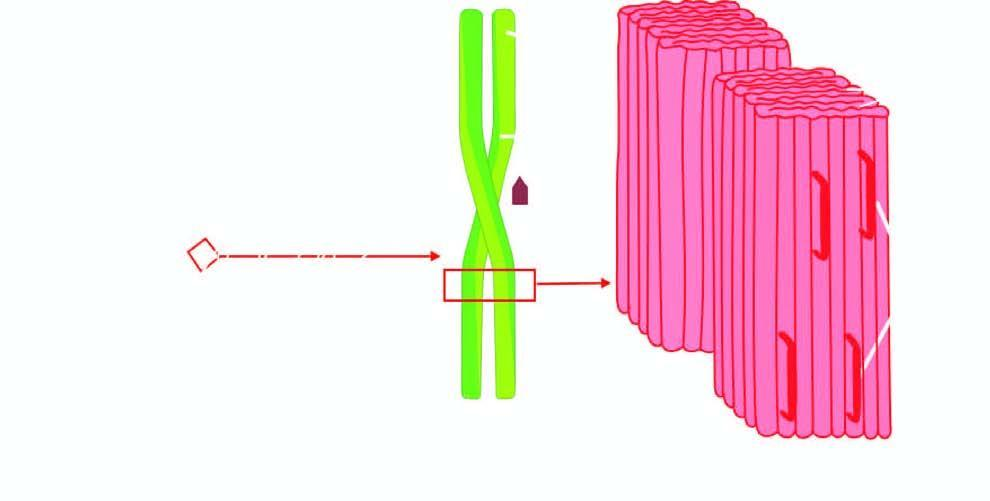s foci of metaplastic squamous epithelium further composed of double helix of two pleated sheets in the form of twin filaments separated by a clear space?
Answer the question using a single word or phrase. No 